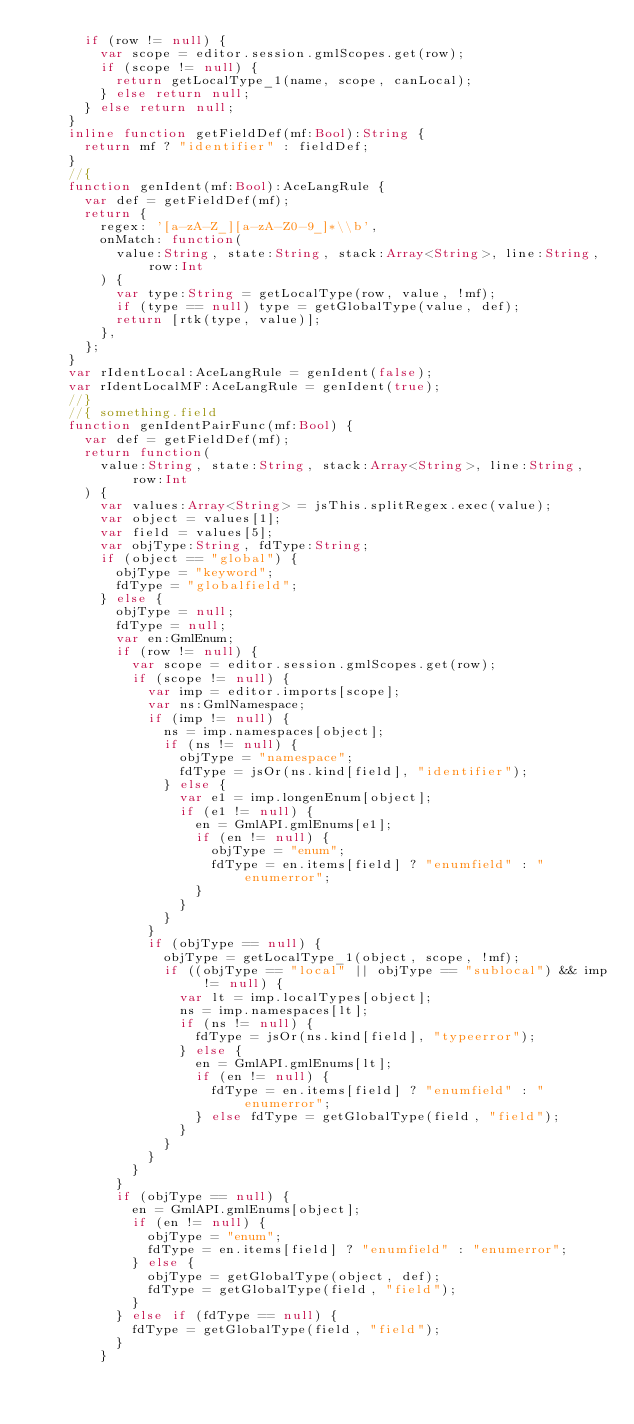<code> <loc_0><loc_0><loc_500><loc_500><_Haxe_>			if (row != null) {
				var scope = editor.session.gmlScopes.get(row);
				if (scope != null) {
					return getLocalType_1(name, scope, canLocal);
				} else return null;
			} else return null;
		}
		inline function getFieldDef(mf:Bool):String {
			return mf ? "identifier" : fieldDef;
		}
		//{
		function genIdent(mf:Bool):AceLangRule {
			var def = getFieldDef(mf);
			return {
				regex: '[a-zA-Z_][a-zA-Z0-9_]*\\b',
				onMatch: function(
					value:String, state:String, stack:Array<String>, line:String, row:Int
				) {
					var type:String = getLocalType(row, value, !mf);
					if (type == null) type = getGlobalType(value, def);
					return [rtk(type, value)];
				},
			};
		}
		var rIdentLocal:AceLangRule = genIdent(false);
		var rIdentLocalMF:AceLangRule = genIdent(true);
		//}
		//{ something.field
		function genIdentPairFunc(mf:Bool) {
			var def = getFieldDef(mf);
			return function(
				value:String, state:String, stack:Array<String>, line:String, row:Int
			) {
				var values:Array<String> = jsThis.splitRegex.exec(value);
				var object = values[1];
				var field = values[5];
				var objType:String, fdType:String;
				if (object == "global") {
					objType = "keyword";
					fdType = "globalfield";
				} else {
					objType = null;
					fdType = null;
					var en:GmlEnum;
					if (row != null) {
						var scope = editor.session.gmlScopes.get(row);
						if (scope != null) {
							var imp = editor.imports[scope];
							var ns:GmlNamespace;
							if (imp != null) {
								ns = imp.namespaces[object];
								if (ns != null) {
									objType = "namespace";
									fdType = jsOr(ns.kind[field], "identifier");
								} else {
									var e1 = imp.longenEnum[object];
									if (e1 != null) {
										en = GmlAPI.gmlEnums[e1];
										if (en != null) {
											objType = "enum";
											fdType = en.items[field] ? "enumfield" : "enumerror";
										}
									}
								}
							}
							if (objType == null) {
								objType = getLocalType_1(object, scope, !mf);
								if ((objType == "local" || objType == "sublocal") && imp != null) {
									var lt = imp.localTypes[object];
									ns = imp.namespaces[lt];
									if (ns != null) {
										fdType = jsOr(ns.kind[field], "typeerror");
									} else {
										en = GmlAPI.gmlEnums[lt];
										if (en != null) {
											fdType = en.items[field] ? "enumfield" : "enumerror";
										} else fdType = getGlobalType(field, "field");
									}
								}
							}
						}
					}
					if (objType == null) {
						en = GmlAPI.gmlEnums[object];
						if (en != null) {
							objType = "enum";
							fdType = en.items[field] ? "enumfield" : "enumerror";
						} else {
							objType = getGlobalType(object, def);
							fdType = getGlobalType(field, "field");
						}
					} else if (fdType == null) {
						fdType = getGlobalType(field, "field");
					}
				}</code> 